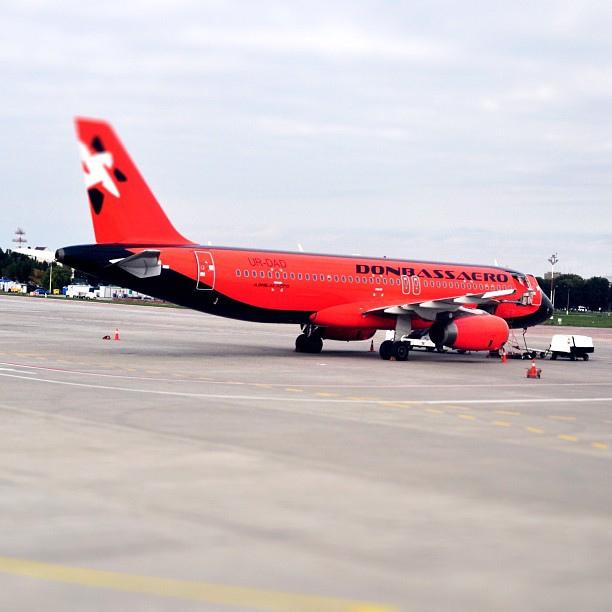Does the aircraft blend into its surroundings?
Give a very brief answer. No. Is the plane flying?
Keep it brief. No. What two colors are the plane made out of?
Short answer required. Red and black. 